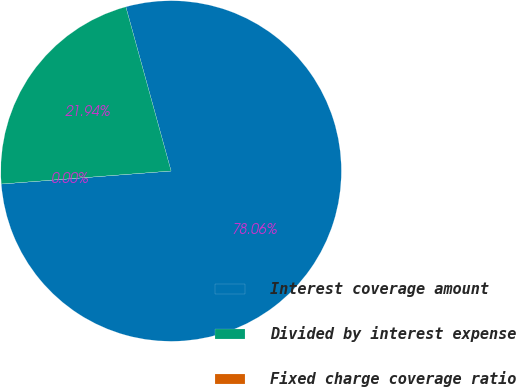<chart> <loc_0><loc_0><loc_500><loc_500><pie_chart><fcel>Interest coverage amount<fcel>Divided by interest expense<fcel>Fixed charge coverage ratio<nl><fcel>78.06%<fcel>21.94%<fcel>0.0%<nl></chart> 